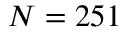Convert formula to latex. <formula><loc_0><loc_0><loc_500><loc_500>N = 2 5 1</formula> 